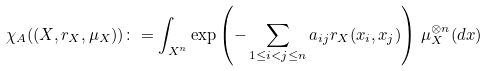Convert formula to latex. <formula><loc_0><loc_0><loc_500><loc_500>\chi _ { A } ( ( X , r _ { X } , \mu _ { X } ) ) \colon = \int _ { X ^ { n } } \exp \left ( - \sum _ { 1 \leq i < j \leq n } a _ { i j } r _ { X } ( x _ { i } , x _ { j } ) \right ) \, \mu _ { X } ^ { \otimes n } ( d x )</formula> 